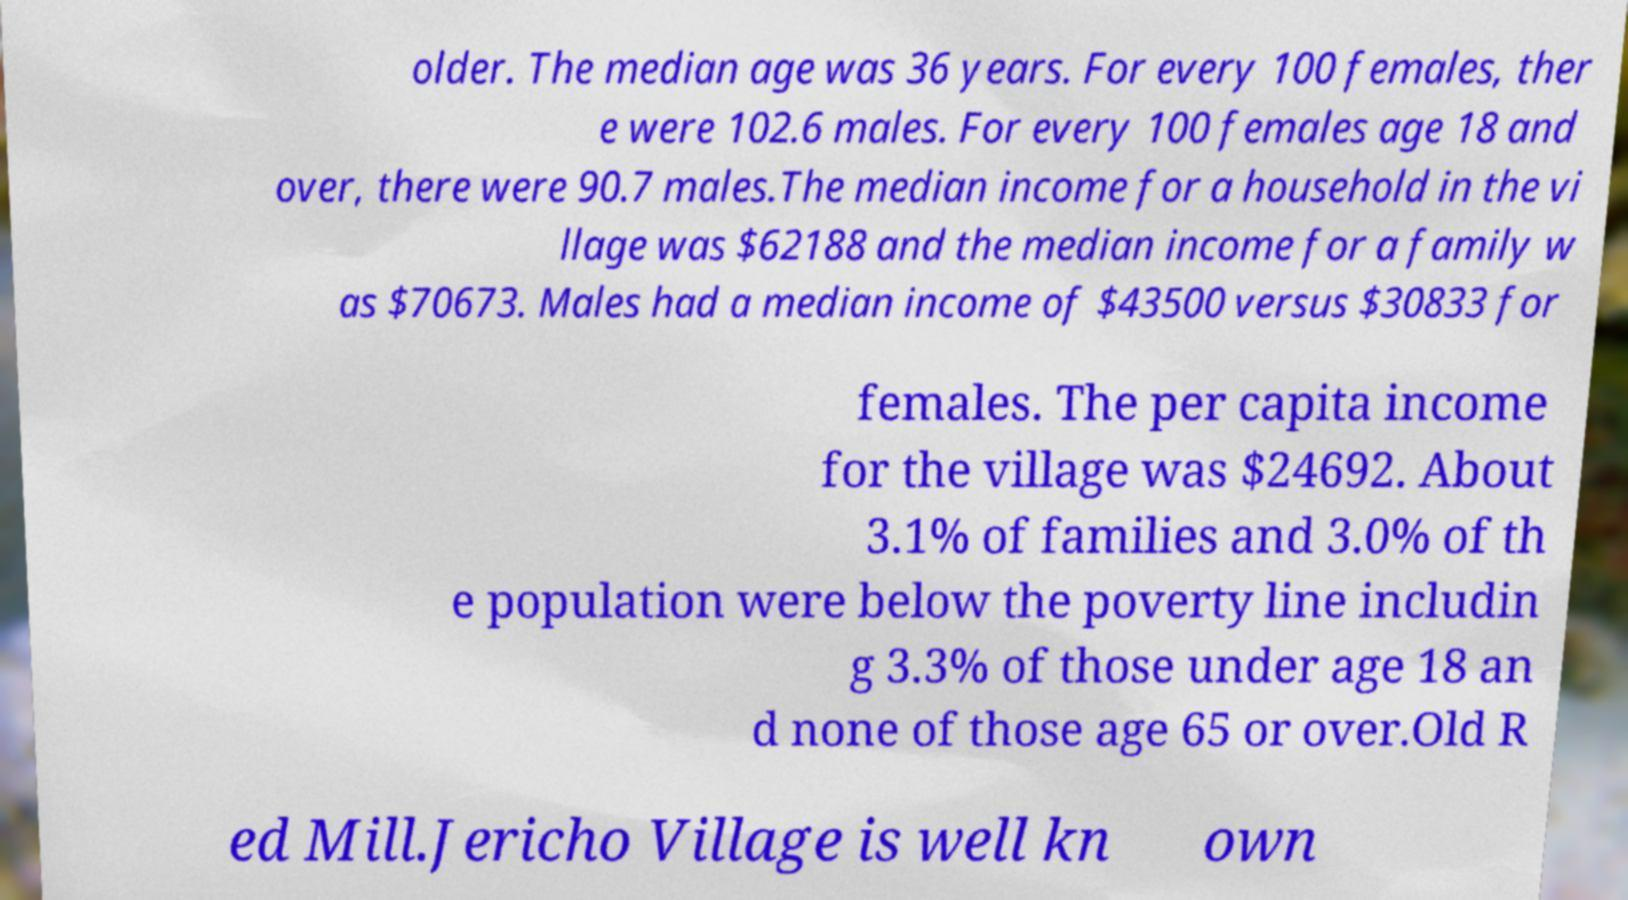Please read and relay the text visible in this image. What does it say? older. The median age was 36 years. For every 100 females, ther e were 102.6 males. For every 100 females age 18 and over, there were 90.7 males.The median income for a household in the vi llage was $62188 and the median income for a family w as $70673. Males had a median income of $43500 versus $30833 for females. The per capita income for the village was $24692. About 3.1% of families and 3.0% of th e population were below the poverty line includin g 3.3% of those under age 18 an d none of those age 65 or over.Old R ed Mill.Jericho Village is well kn own 